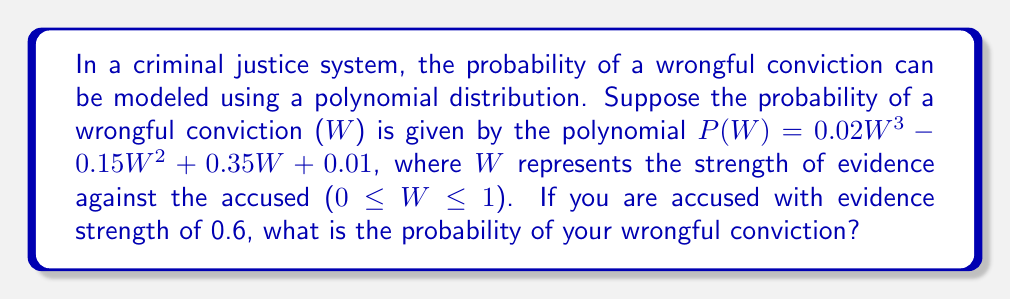Can you answer this question? To solve this problem, we need to follow these steps:

1. Identify the given polynomial: 
   $P(W) = 0.02W^3 - 0.15W^2 + 0.35W + 0.01$

2. Substitute the given evidence strength (W = 0.6) into the polynomial:
   $P(0.6) = 0.02(0.6)^3 - 0.15(0.6)^2 + 0.35(0.6) + 0.01$

3. Calculate each term:
   - $0.02(0.6)^3 = 0.02 * 0.216 = 0.00432$
   - $-0.15(0.6)^2 = -0.15 * 0.36 = -0.054$
   - $0.35(0.6) = 0.21$
   - $0.01$ (constant term)

4. Sum up all the terms:
   $P(0.6) = 0.00432 - 0.054 + 0.21 + 0.01 = 0.17032$

5. Round the result to 4 decimal places:
   $P(0.6) ≈ 0.1703$

Therefore, the probability of a wrongful conviction with evidence strength of 0.6 is approximately 0.1703 or 17.03%.
Answer: 0.1703 